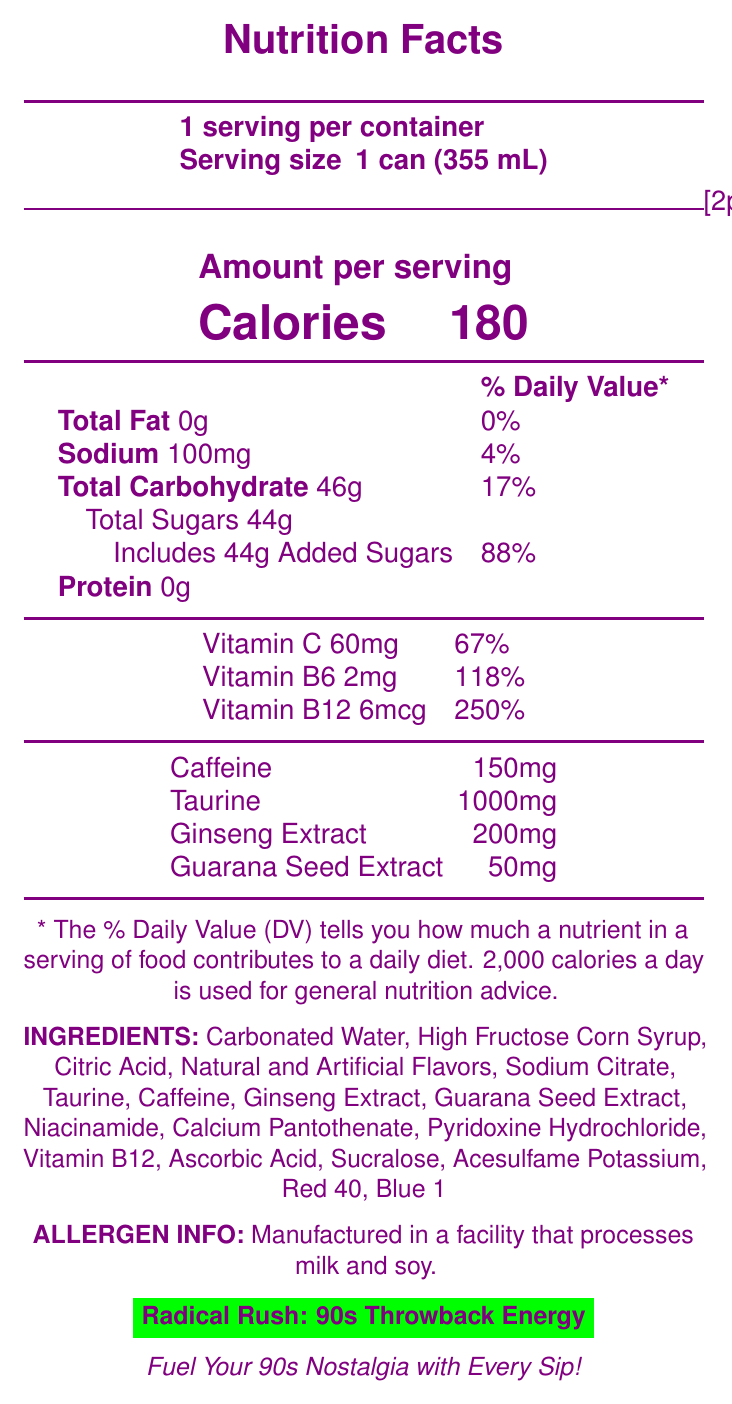what is the serving size for Radical Rush: 90s Throwback Energy? The serving size is clearly listed as "1 can (355 mL)" in the nutrition facts.
Answer: 1 can (355 mL) how many calories are in a single serving? The number of calories per serving is specified as 180 in the document.
Answer: 180 how much vitamin C is in one serving of Radical Rush? The document states that each serving contains 60mg of Vitamin C.
Answer: 60mg what is the amount of added sugars per serving and its daily value percentage? The document lists 44g of added sugars and mentions that this constitutes 88% of the daily value.
Answer: 44g, 88% does Radical Rush contain any protein? According to the nutrition facts, the amount of protein per serving is 0g.
Answer: No which of the following is not an ingredient of Radical Rush? A. Citric Acid B. Niacinamide C. Soy Lecithin Soy Lecithin is not listed as an ingredient in the document.
Answer: C. Soy Lecithin what is the daily value percentage of Vitamin B12 in one can? A. 67% B. 118% C. 250% D. 88% The document states that Vitamin B12 has a daily value percentage of 250%.
Answer: C. 250% is the product allergen information available on the document? The document includes allergen information, stating, "Manufactured in a facility that processes milk and soy."
Answer: Yes summarize the main idea of the document. The document is essentially a comprehensive breakdown of the nutritional information and ingredients of an energy drink inspired by the 90s, along with its packaging and marketing attributes.
Answer: The document provides the detailed nutrition facts label of "Radical Rush: 90s Throwback Energy," highlighting its serving size, calories, nutritional content, ingredients, allergen information, and nostalgic marketing elements. where is Radical Rush: 90s Throwback Energy distributed? The document states that this energy drink is distributed at select record stores and 90s-themed events.
Answer: Available at select record stores and 90s-themed events how much caffeine does each can of Radical Rush contain? The document specifies that each serving contains 150mg of caffeine.
Answer: 150mg what is the marketing tagline for Radical Rush? The document features the tagline "Fuel Your 90s Nostalgia with Every Sip!" prominently.
Answer: Fuel Your 90s Nostalgia with Every Sip! how many grams of total carbohydrates are there in one serving? The document lists the total carbohydrates per serving as 46g.
Answer: 46g are there any artificial sweeteners listed in the ingredients? The document lists Sucralose and Acesulfame Potassium among the ingredients, which are artificial sweeteners.
Answer: Yes, Sucralose and Acesulfame Potassium can the percentage of daily value for sodium per serving be determined from the document? A. Yes B. No According to the document, the daily value percentage for sodium is 4% per serving.
Answer: A. Yes how much taurine is in Radical Rush? The document specifies that each serving contains 1000mg of taurine.
Answer: 1000mg does the document give information about the origin or sourcing of the ingredients used? The document does not provide any details about the origin or sourcing of the ingredients.
Answer: Cannot be determined 